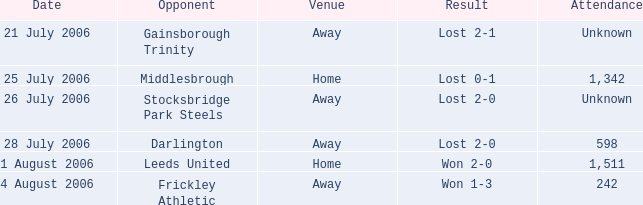Which rival has uncertain participation, and lost 2-0? Stocksbridge Park Steels. 